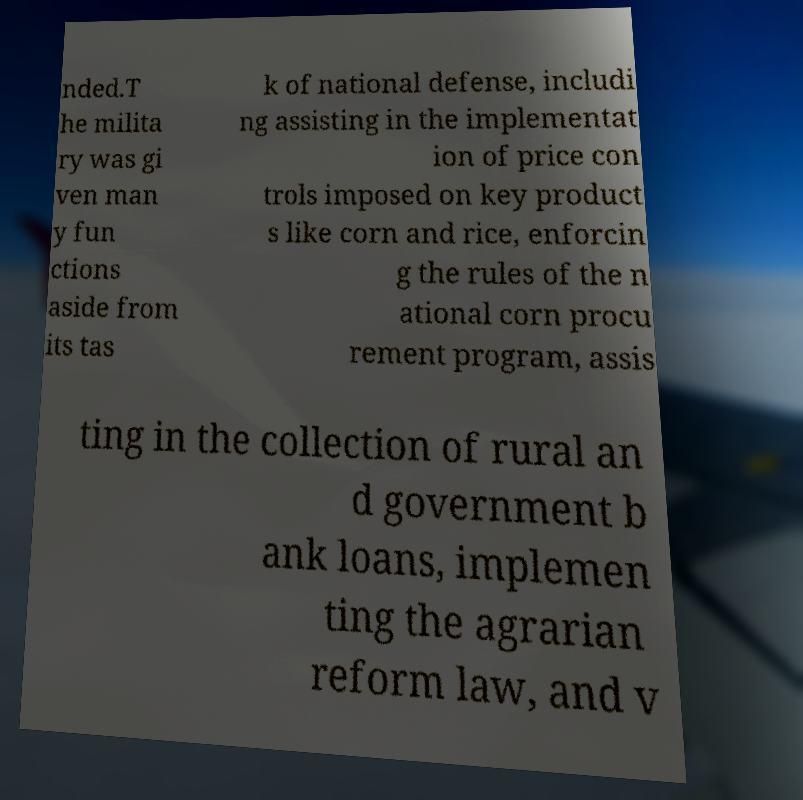Please read and relay the text visible in this image. What does it say? nded.T he milita ry was gi ven man y fun ctions aside from its tas k of national defense, includi ng assisting in the implementat ion of price con trols imposed on key product s like corn and rice, enforcin g the rules of the n ational corn procu rement program, assis ting in the collection of rural an d government b ank loans, implemen ting the agrarian reform law, and v 